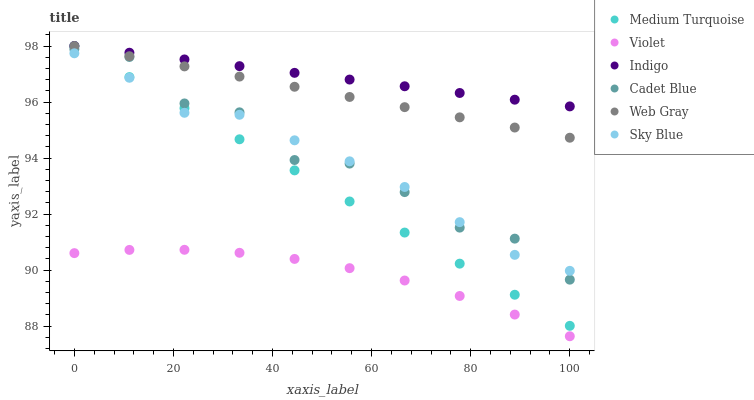Does Violet have the minimum area under the curve?
Answer yes or no. Yes. Does Indigo have the maximum area under the curve?
Answer yes or no. Yes. Does Cadet Blue have the minimum area under the curve?
Answer yes or no. No. Does Cadet Blue have the maximum area under the curve?
Answer yes or no. No. Is Indigo the smoothest?
Answer yes or no. Yes. Is Cadet Blue the roughest?
Answer yes or no. Yes. Is Cadet Blue the smoothest?
Answer yes or no. No. Is Indigo the roughest?
Answer yes or no. No. Does Violet have the lowest value?
Answer yes or no. Yes. Does Cadet Blue have the lowest value?
Answer yes or no. No. Does Medium Turquoise have the highest value?
Answer yes or no. Yes. Does Cadet Blue have the highest value?
Answer yes or no. No. Is Violet less than Web Gray?
Answer yes or no. Yes. Is Medium Turquoise greater than Violet?
Answer yes or no. Yes. Does Cadet Blue intersect Sky Blue?
Answer yes or no. Yes. Is Cadet Blue less than Sky Blue?
Answer yes or no. No. Is Cadet Blue greater than Sky Blue?
Answer yes or no. No. Does Violet intersect Web Gray?
Answer yes or no. No. 